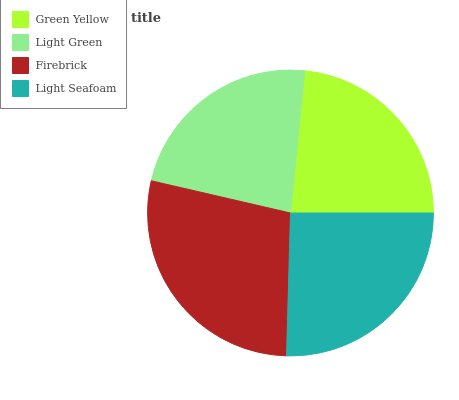Is Light Green the minimum?
Answer yes or no. Yes. Is Firebrick the maximum?
Answer yes or no. Yes. Is Firebrick the minimum?
Answer yes or no. No. Is Light Green the maximum?
Answer yes or no. No. Is Firebrick greater than Light Green?
Answer yes or no. Yes. Is Light Green less than Firebrick?
Answer yes or no. Yes. Is Light Green greater than Firebrick?
Answer yes or no. No. Is Firebrick less than Light Green?
Answer yes or no. No. Is Light Seafoam the high median?
Answer yes or no. Yes. Is Green Yellow the low median?
Answer yes or no. Yes. Is Firebrick the high median?
Answer yes or no. No. Is Light Seafoam the low median?
Answer yes or no. No. 